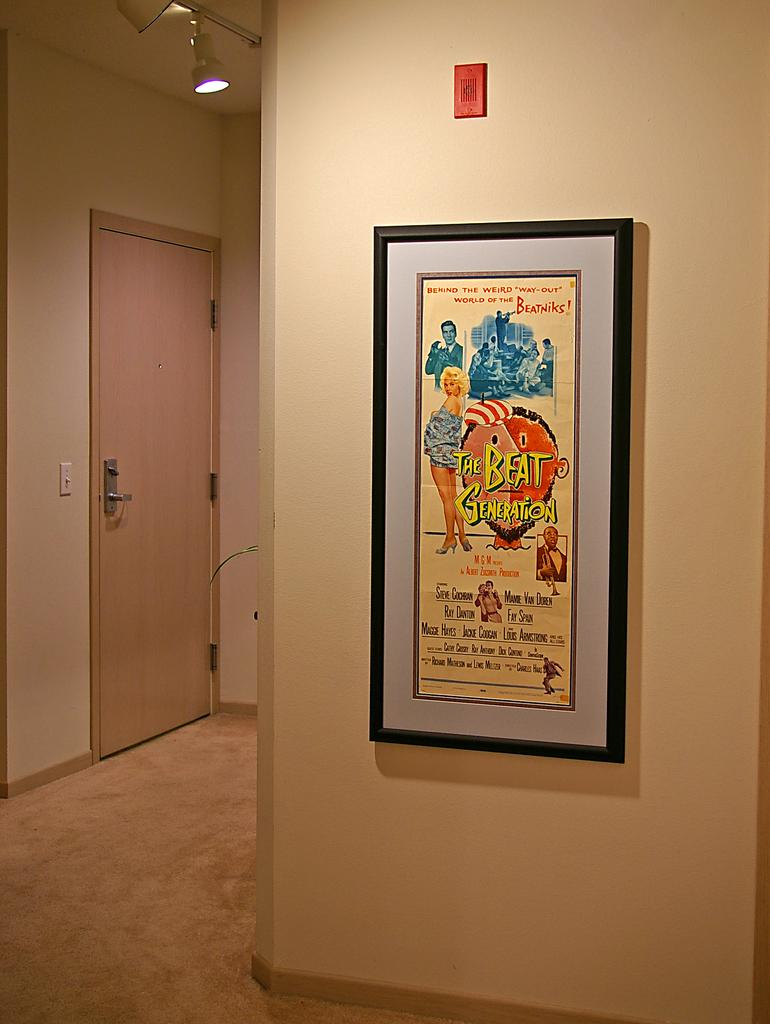<image>
Share a concise interpretation of the image provided. A framed poster for a movie called The Beat Generation. 